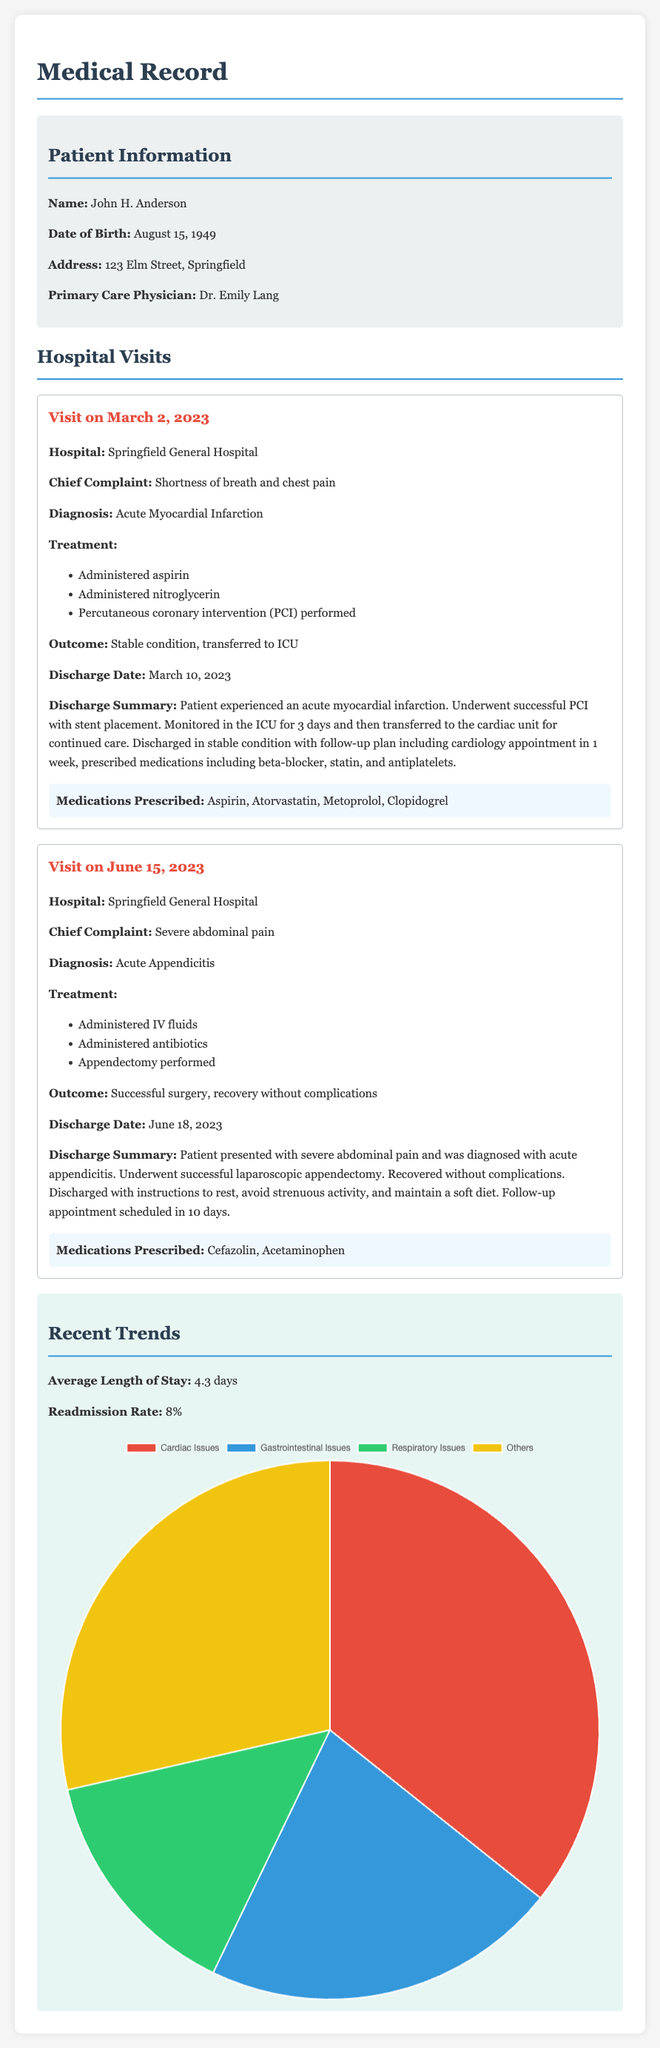What is the name of the patient? The patient's name is explicitly stated in the document under the patient information section.
Answer: John H. Anderson What was the chief complaint during the visit on March 2, 2023? The document lists the chief complaint under the March 2, 2023 visit description.
Answer: Shortness of breath and chest pain When was the diagnosis for acute appendicitis made? The diagnosis date is inferred from the visit date of June 15, 2023, as it occurs during that visit.
Answer: June 15, 2023 How many days was the patient in the hospital for the first visit? The document provides the discharge date and admission information related to the first visit to calculate the length of stay.
Answer: 8 days What medications were prescribed after the visit on March 2, 2023? The medications prescribed are listed clearly in the discharge summary for that visit.
Answer: Aspirin, Atorvastatin, Metoprolol, Clopidogrel What was the treatment performed during the June 15, 2023 visit? The treatment for the June visit is outlined in the treatment section of that visit's details.
Answer: Appendectomy What is the average length of stay reported in the trends section? The average length of stay is stated directly under the trends section of the document.
Answer: 4.3 days What condition had the highest number of admissions according to the pie chart? The pie chart data illustrates condition admission numbers, allowing identification of the highest one.
Answer: Cardiac Issues 